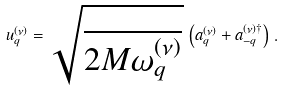Convert formula to latex. <formula><loc_0><loc_0><loc_500><loc_500>u _ { q } ^ { ( \nu ) } = \sqrt { \frac { } { 2 M \omega _ { q } ^ { ( \nu ) } } } \, \left ( a ^ { ( \nu ) } _ { q } + a ^ { ( \nu ) \dagger } _ { - q } \right ) \, .</formula> 